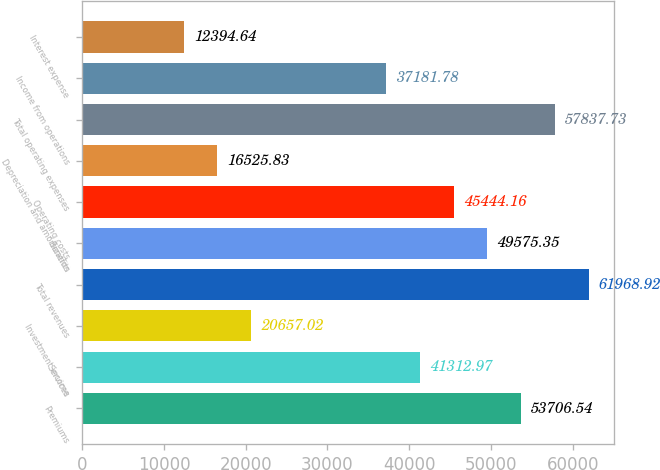Convert chart to OTSL. <chart><loc_0><loc_0><loc_500><loc_500><bar_chart><fcel>Premiums<fcel>Services<fcel>Investment income<fcel>Total revenues<fcel>Benefits<fcel>Operating costs<fcel>Depreciation and amortization<fcel>Total operating expenses<fcel>Income from operations<fcel>Interest expense<nl><fcel>53706.5<fcel>41313<fcel>20657<fcel>61968.9<fcel>49575.3<fcel>45444.2<fcel>16525.8<fcel>57837.7<fcel>37181.8<fcel>12394.6<nl></chart> 